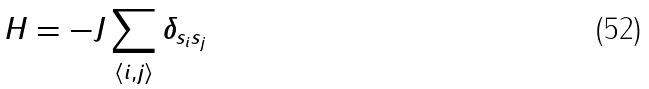<formula> <loc_0><loc_0><loc_500><loc_500>H = - J \sum _ { \langle i , j \rangle } \delta _ { { s _ { i } } { s _ { j } } }</formula> 